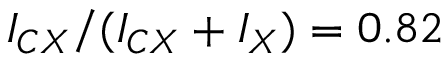Convert formula to latex. <formula><loc_0><loc_0><loc_500><loc_500>I _ { C X } / ( I _ { C X } + I _ { X } ) = 0 . 8 2</formula> 